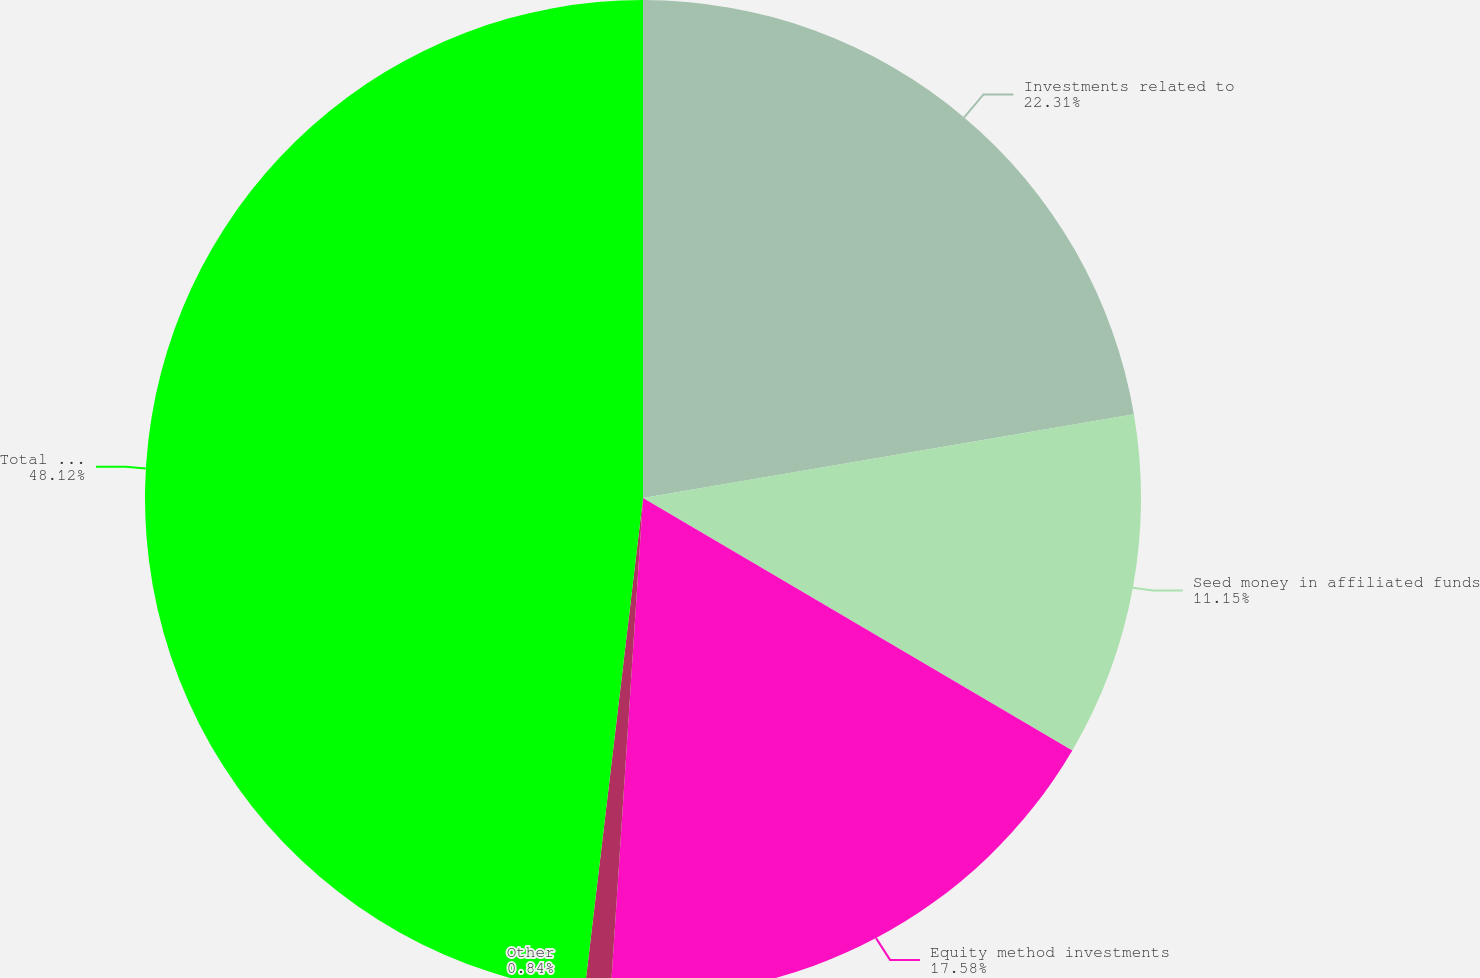Convert chart. <chart><loc_0><loc_0><loc_500><loc_500><pie_chart><fcel>Investments related to<fcel>Seed money in affiliated funds<fcel>Equity method investments<fcel>Other<fcel>Total market risk on<nl><fcel>22.31%<fcel>11.15%<fcel>17.58%<fcel>0.84%<fcel>48.12%<nl></chart> 